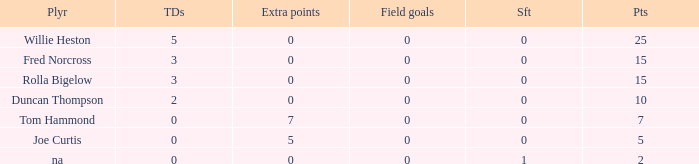Which Points is the lowest one that has Touchdowns smaller than 2, and an Extra points of 7, and a Field goals smaller than 0? None. 